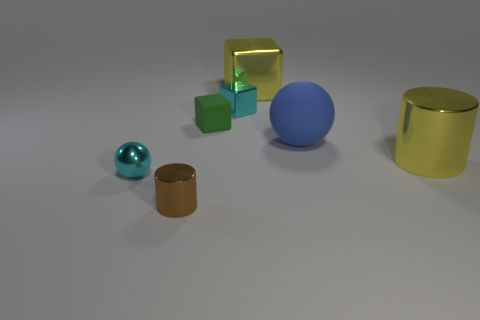What number of objects are cubes that are to the left of the yellow cube or small metal objects to the left of the small brown metallic object?
Provide a succinct answer. 3. How many cyan objects are shiny cylinders or tiny matte objects?
Ensure brevity in your answer.  0. There is a object that is to the right of the tiny cyan cube and in front of the large blue matte sphere; what is it made of?
Provide a succinct answer. Metal. Is the material of the tiny cyan cube the same as the large cylinder?
Your response must be concise. Yes. How many brown cylinders have the same size as the cyan sphere?
Your answer should be very brief. 1. Are there an equal number of yellow things behind the big cylinder and big blue things?
Provide a succinct answer. Yes. How many small metallic things are in front of the yellow metal cylinder and behind the small brown object?
Offer a terse response. 1. Do the large thing right of the big sphere and the brown metal thing have the same shape?
Ensure brevity in your answer.  Yes. There is a brown thing that is the same size as the cyan shiny block; what is it made of?
Make the answer very short. Metal. Is the number of small cyan objects in front of the big ball the same as the number of tiny green matte things in front of the yellow metal cylinder?
Ensure brevity in your answer.  No. 